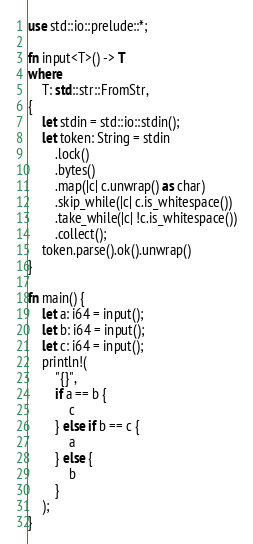<code> <loc_0><loc_0><loc_500><loc_500><_Rust_>use std::io::prelude::*;

fn input<T>() -> T
where
    T: std::str::FromStr,
{
    let stdin = std::io::stdin();
    let token: String = stdin
        .lock()
        .bytes()
        .map(|c| c.unwrap() as char)
        .skip_while(|c| c.is_whitespace())
        .take_while(|c| !c.is_whitespace())
        .collect();
    token.parse().ok().unwrap()
}

fn main() {
    let a: i64 = input();
    let b: i64 = input();
    let c: i64 = input();
    println!(
        "{}",
        if a == b {
            c
        } else if b == c {
            a
        } else {
            b
        }
    );
}
</code> 